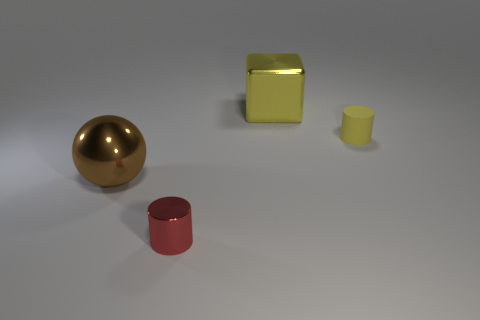Is there anything else that has the same material as the tiny yellow thing?
Give a very brief answer. No. Are there any big balls made of the same material as the red thing?
Give a very brief answer. Yes. What is the size of the thing that is behind the cylinder that is behind the brown shiny thing?
Give a very brief answer. Large. Are there more big cubes than tiny red balls?
Your answer should be very brief. Yes. Is the size of the yellow thing that is in front of the yellow block the same as the big metallic block?
Provide a short and direct response. No. What number of large metal cubes are the same color as the small matte cylinder?
Give a very brief answer. 1. Does the small yellow thing have the same shape as the yellow shiny thing?
Offer a very short reply. No. Are there any other things that have the same size as the brown thing?
Your answer should be compact. Yes. What is the size of the red thing that is the same shape as the small yellow object?
Keep it short and to the point. Small. Is the number of large things behind the small yellow thing greater than the number of small things left of the metallic cylinder?
Offer a very short reply. Yes. 